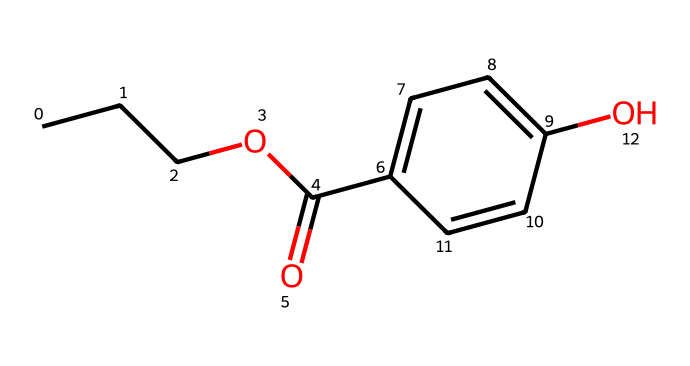What is the molecular formula of propylparaben? To determine the molecular formula, count the atoms of each element in the SMILES representation. The structure corresponds to 10 carbons (C), 12 hydrogens (H), 4 oxygens (O), yielding the formula C10H12O4.
Answer: C10H12O4 How many rings are present in the structure of propylparaben? Observe the structure; there is one cyclic part (ring) in the molecular structure, which is indicated by the connections in the aromatic part (C1=CC=C).
Answer: 1 What functional groups are present in propylparaben? Analyze the chemical structure to identify functional groups. The ester group (-COO-) and hydroxyl group (-OH) are present, which are key functional groups in preservatives.
Answer: ester and hydroxyl What is the main role of propylparaben in furniture polishes? Propylparaben is a type of preservative that prevents microbial growth, thereby extending the shelf life of products like furniture polish, which is essential for maintaining product quality.
Answer: preservative Why does propylparaben have preservative properties? The chemical structure contains hydroxyl groups, which can interact with microbial cell components, disrupting their function and preventing spoilage, making it an effective antimicrobial agent.
Answer: antimicrobial agent 